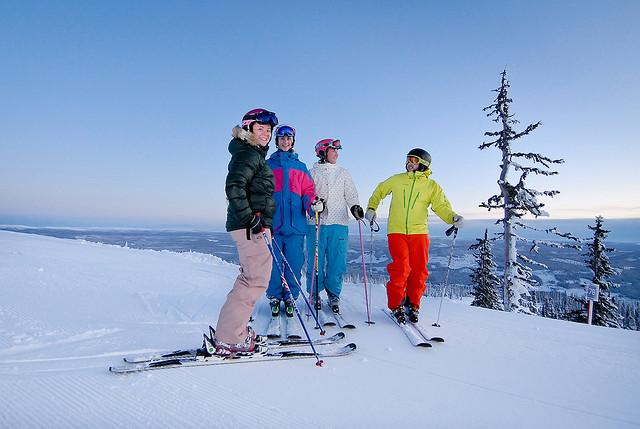Why are they stopped? taking break 